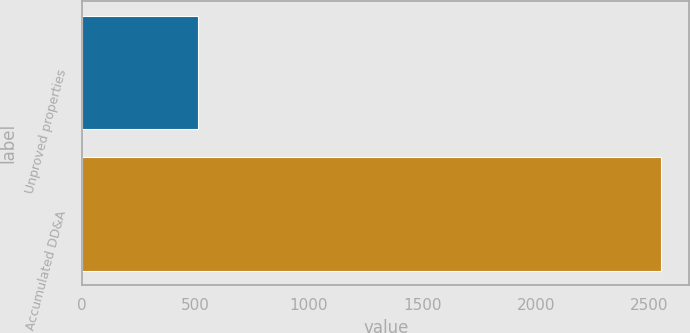<chart> <loc_0><loc_0><loc_500><loc_500><bar_chart><fcel>Unproved properties<fcel>Accumulated DD&A<nl><fcel>513<fcel>2550<nl></chart> 